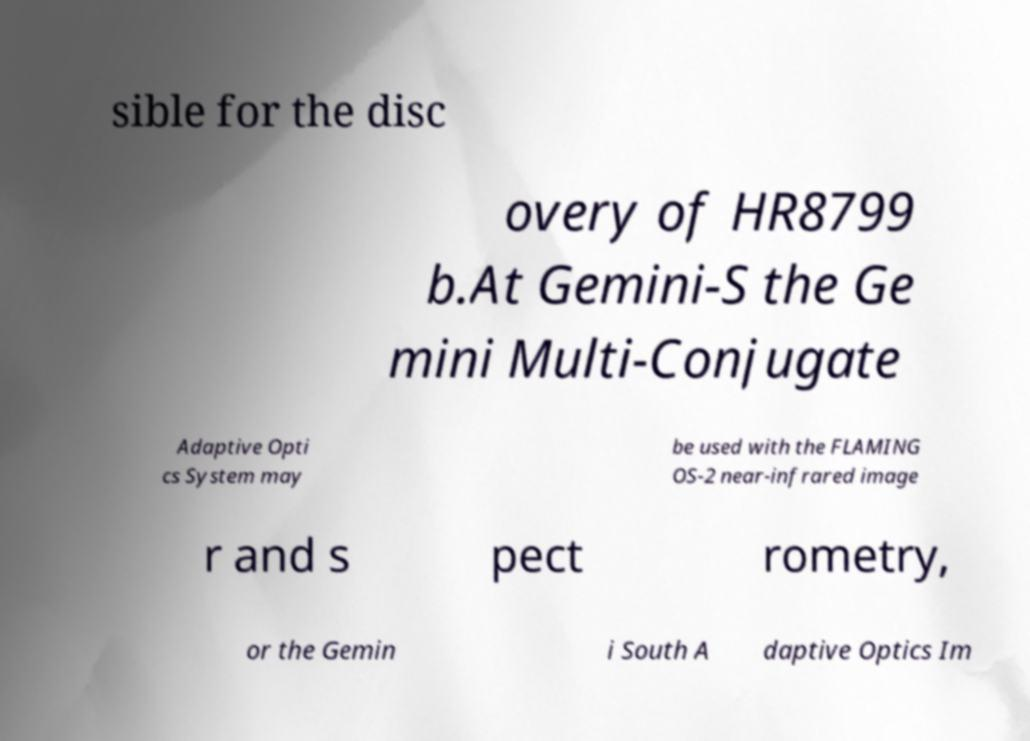What messages or text are displayed in this image? I need them in a readable, typed format. sible for the disc overy of HR8799 b.At Gemini-S the Ge mini Multi-Conjugate Adaptive Opti cs System may be used with the FLAMING OS-2 near-infrared image r and s pect rometry, or the Gemin i South A daptive Optics Im 